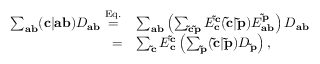Convert formula to latex. <formula><loc_0><loc_0><loc_500><loc_500>\begin{array} { r l } { \sum _ { a b } ( c | a b ) D _ { a b } \overset { E q . \, } { = } } & { \sum _ { a b } \left ( \sum _ { \tilde { c } \tilde { p } } E _ { c } ^ { \tilde { c } } ( \tilde { c } | \tilde { p } ) E _ { a b } ^ { \tilde { p } } \right ) D _ { a b } } \\ { = } & { \sum _ { \tilde { c } } E _ { c } ^ { \tilde { c } } \left ( \sum _ { \tilde { p } } ( \tilde { c } | \tilde { p } ) D _ { \tilde { p } } \right ) , } \end{array}</formula> 